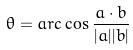<formula> <loc_0><loc_0><loc_500><loc_500>\theta = a r c \cos \frac { a \cdot b } { | a | | b | }</formula> 